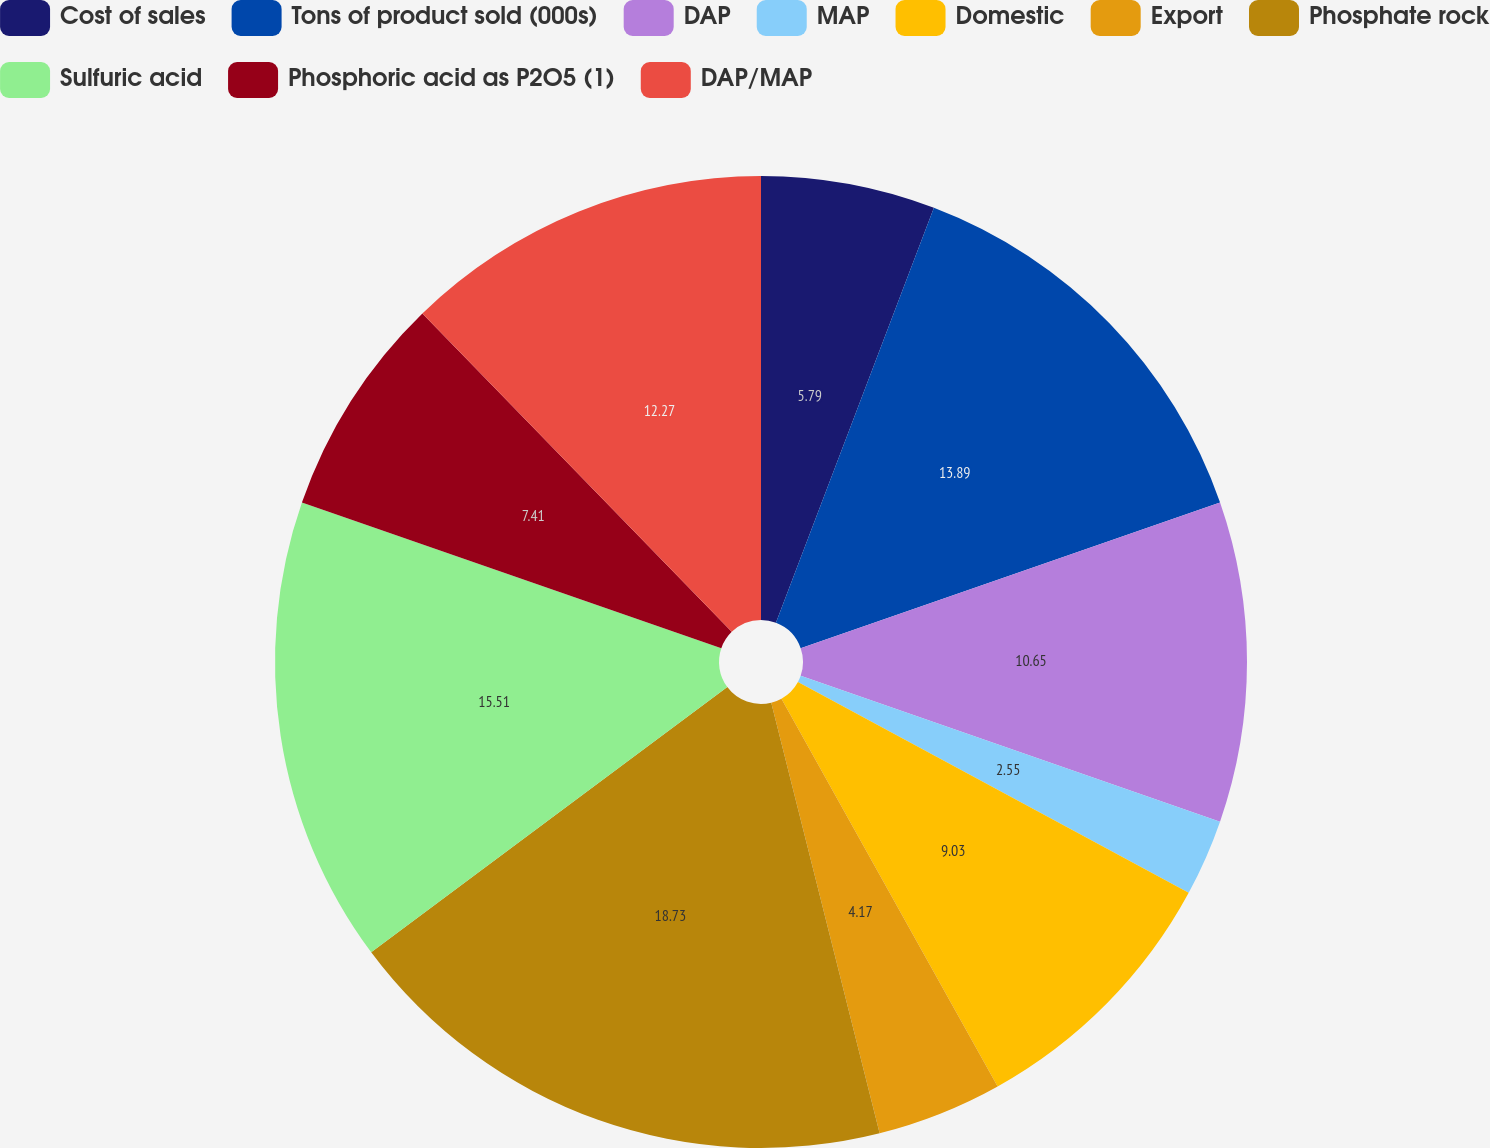Convert chart to OTSL. <chart><loc_0><loc_0><loc_500><loc_500><pie_chart><fcel>Cost of sales<fcel>Tons of product sold (000s)<fcel>DAP<fcel>MAP<fcel>Domestic<fcel>Export<fcel>Phosphate rock<fcel>Sulfuric acid<fcel>Phosphoric acid as P2O5 (1)<fcel>DAP/MAP<nl><fcel>5.79%<fcel>13.89%<fcel>10.65%<fcel>2.55%<fcel>9.03%<fcel>4.17%<fcel>18.74%<fcel>15.51%<fcel>7.41%<fcel>12.27%<nl></chart> 